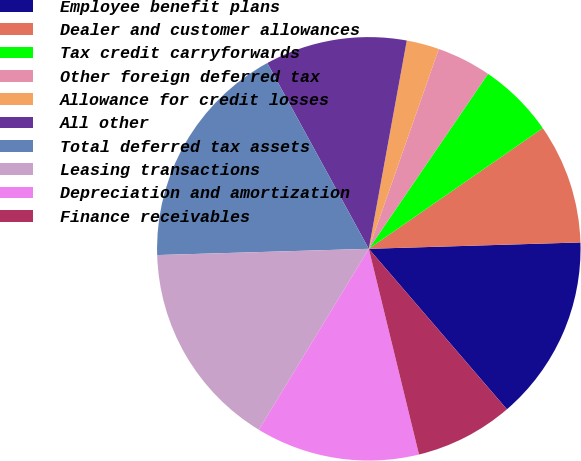Convert chart. <chart><loc_0><loc_0><loc_500><loc_500><pie_chart><fcel>Employee benefit plans<fcel>Dealer and customer allowances<fcel>Tax credit carryforwards<fcel>Other foreign deferred tax<fcel>Allowance for credit losses<fcel>All other<fcel>Total deferred tax assets<fcel>Leasing transactions<fcel>Depreciation and amortization<fcel>Finance receivables<nl><fcel>14.17%<fcel>9.17%<fcel>5.83%<fcel>4.16%<fcel>2.49%<fcel>10.83%<fcel>17.51%<fcel>15.84%<fcel>12.5%<fcel>7.5%<nl></chart> 